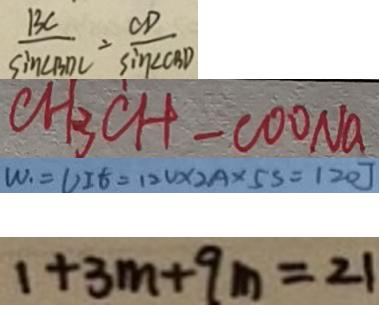<formula> <loc_0><loc_0><loc_500><loc_500>\frac { B C } { \sin \angle B D C } = \frac { O D } { \sin \angle C B D } 
 C H _ { 3 } C H - C O O N a 
 W _ { 1 } = U I t = 1 2 V \times 2 A \times 5 s = 1 2 0 J 
 1 + 3 m + 9 m = 2 1</formula> 